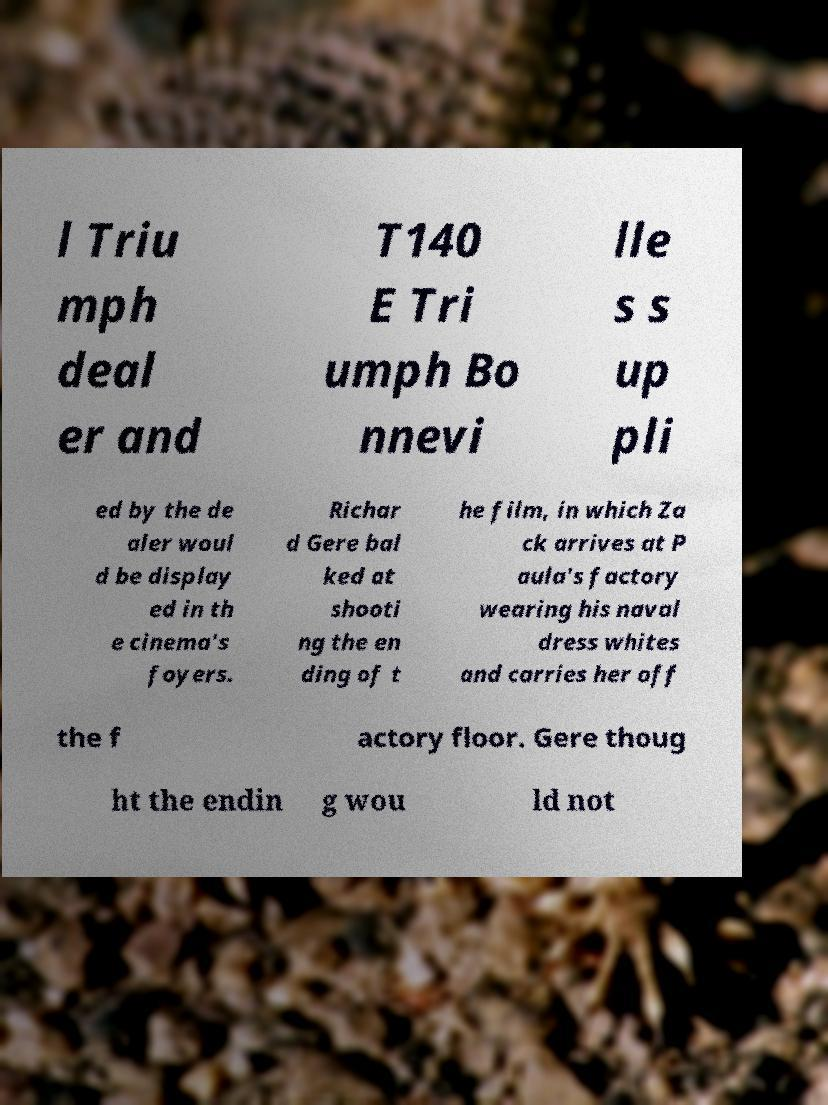Please identify and transcribe the text found in this image. l Triu mph deal er and T140 E Tri umph Bo nnevi lle s s up pli ed by the de aler woul d be display ed in th e cinema's foyers. Richar d Gere bal ked at shooti ng the en ding of t he film, in which Za ck arrives at P aula's factory wearing his naval dress whites and carries her off the f actory floor. Gere thoug ht the endin g wou ld not 